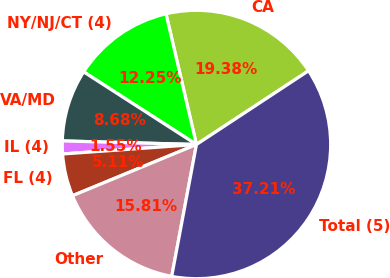Convert chart. <chart><loc_0><loc_0><loc_500><loc_500><pie_chart><fcel>CA<fcel>NY/NJ/CT (4)<fcel>VA/MD<fcel>IL (4)<fcel>FL (4)<fcel>Other<fcel>Total (5)<nl><fcel>19.38%<fcel>12.25%<fcel>8.68%<fcel>1.55%<fcel>5.11%<fcel>15.81%<fcel>37.21%<nl></chart> 